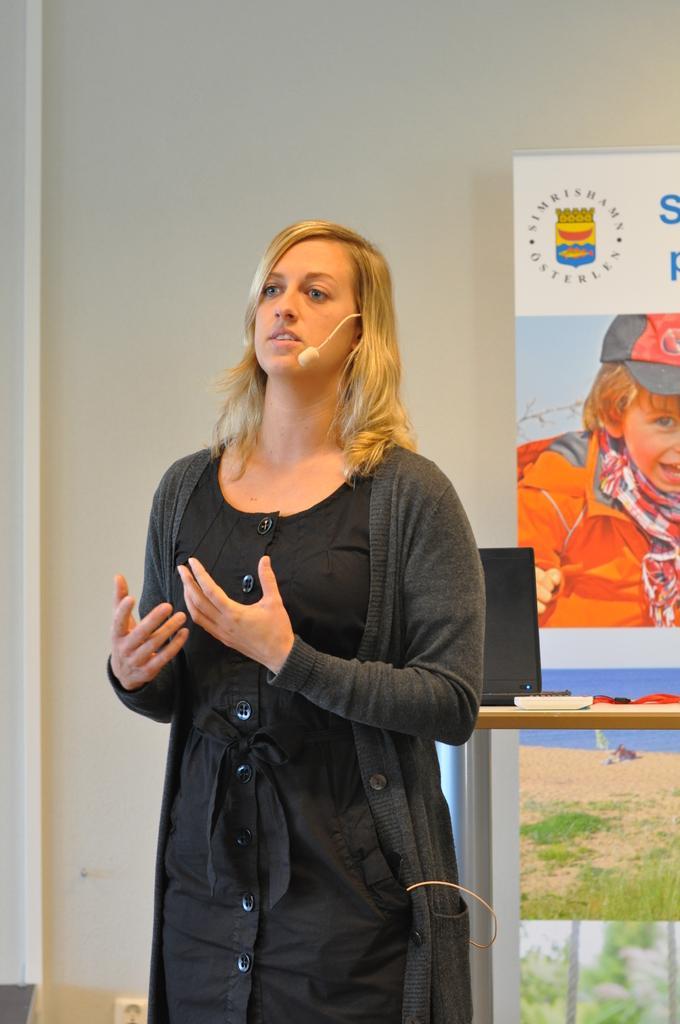Please provide a concise description of this image. In the background we can see the wall, board and few objects. In this picture we can see a woman wearing a black dress, microphone and looks like she is talking. She is standing. 